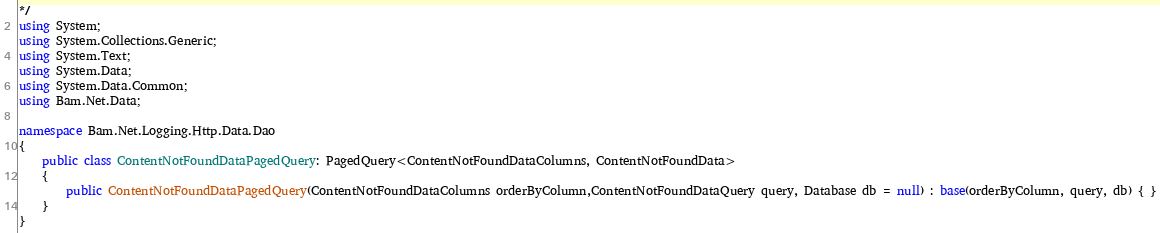<code> <loc_0><loc_0><loc_500><loc_500><_C#_>*/
using System;
using System.Collections.Generic;
using System.Text;
using System.Data;
using System.Data.Common;
using Bam.Net.Data;

namespace Bam.Net.Logging.Http.Data.Dao
{
    public class ContentNotFoundDataPagedQuery: PagedQuery<ContentNotFoundDataColumns, ContentNotFoundData>
    { 
		public ContentNotFoundDataPagedQuery(ContentNotFoundDataColumns orderByColumn,ContentNotFoundDataQuery query, Database db = null) : base(orderByColumn, query, db) { }
    }
}</code> 